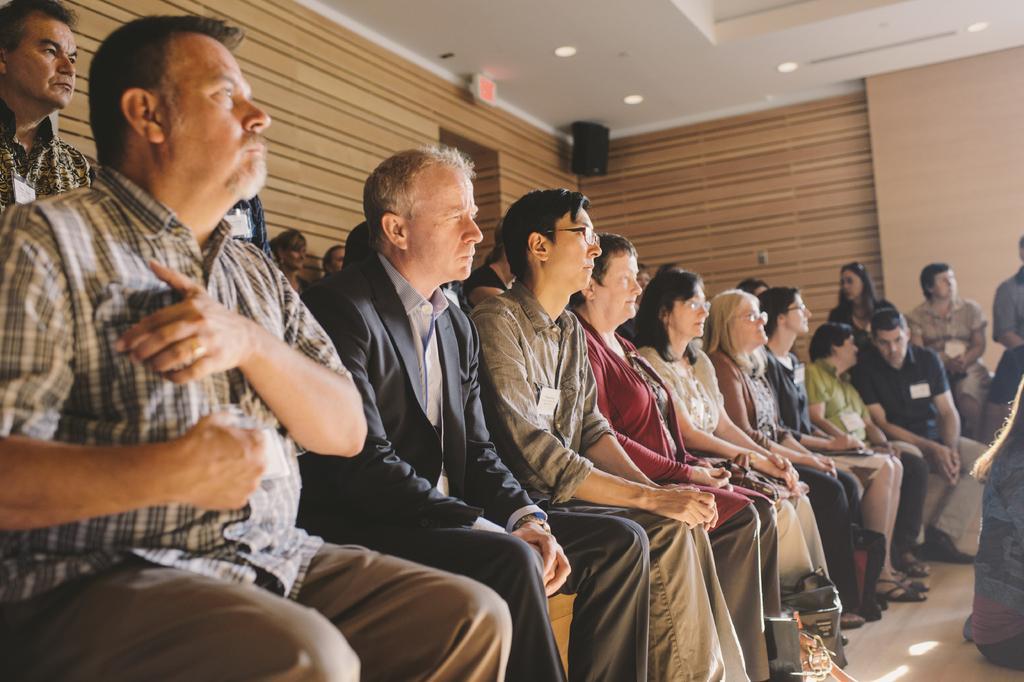Could you give a brief overview of what you see in this image? In this image we can see many person sitting on the chairs. In the background we can see persons, wall, speaker and door. 